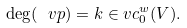Convert formula to latex. <formula><loc_0><loc_0><loc_500><loc_500>\deg ( \ v p ) = k \in v c _ { 0 } ^ { w } ( V ) .</formula> 